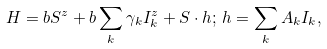<formula> <loc_0><loc_0><loc_500><loc_500>H = b S ^ { z } + b \sum _ { k } \gamma _ { k } I _ { k } ^ { z } + S \cdot h ; \, h = \sum _ { k } A _ { k } I _ { k } ,</formula> 